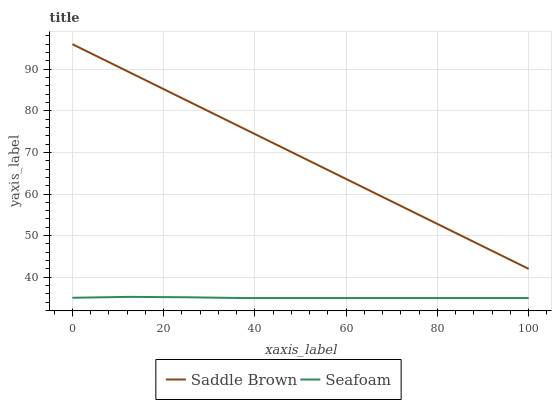Does Seafoam have the minimum area under the curve?
Answer yes or no. Yes. Does Saddle Brown have the maximum area under the curve?
Answer yes or no. Yes. Does Seafoam have the maximum area under the curve?
Answer yes or no. No. Is Saddle Brown the smoothest?
Answer yes or no. Yes. Is Seafoam the roughest?
Answer yes or no. Yes. Is Seafoam the smoothest?
Answer yes or no. No. Does Seafoam have the lowest value?
Answer yes or no. Yes. Does Saddle Brown have the highest value?
Answer yes or no. Yes. Does Seafoam have the highest value?
Answer yes or no. No. Is Seafoam less than Saddle Brown?
Answer yes or no. Yes. Is Saddle Brown greater than Seafoam?
Answer yes or no. Yes. Does Seafoam intersect Saddle Brown?
Answer yes or no. No. 